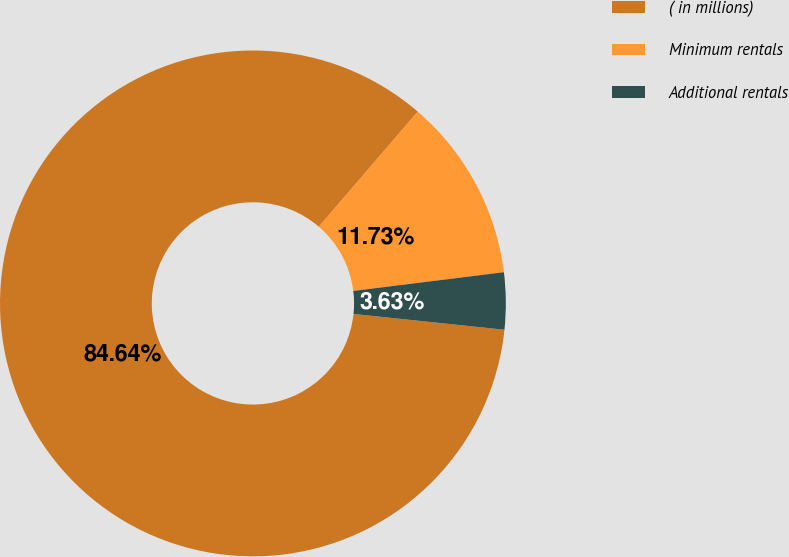Convert chart. <chart><loc_0><loc_0><loc_500><loc_500><pie_chart><fcel>( in millions)<fcel>Minimum rentals<fcel>Additional rentals<nl><fcel>84.64%<fcel>11.73%<fcel>3.63%<nl></chart> 